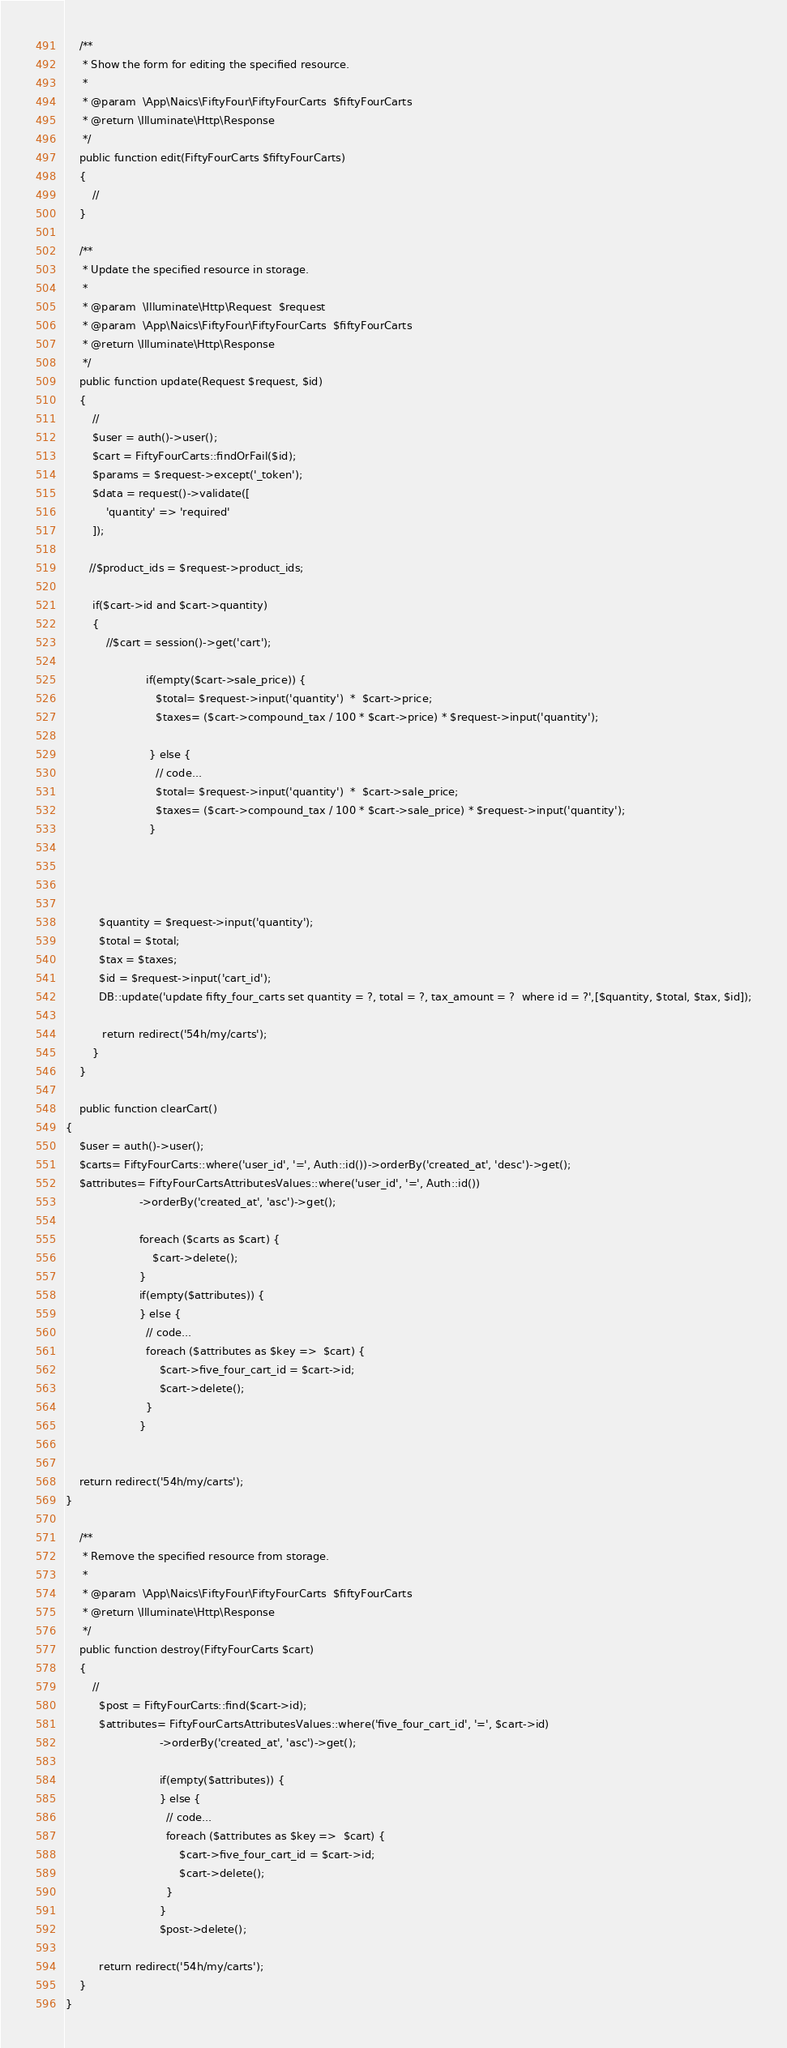Convert code to text. <code><loc_0><loc_0><loc_500><loc_500><_PHP_>    /**
     * Show the form for editing the specified resource.
     *
     * @param  \App\Naics\FiftyFour\FiftyFourCarts  $fiftyFourCarts
     * @return \Illuminate\Http\Response
     */
    public function edit(FiftyFourCarts $fiftyFourCarts)
    {
        //
    }

    /**
     * Update the specified resource in storage.
     *
     * @param  \Illuminate\Http\Request  $request
     * @param  \App\Naics\FiftyFour\FiftyFourCarts  $fiftyFourCarts
     * @return \Illuminate\Http\Response
     */
    public function update(Request $request, $id)
    {
        //
        $user = auth()->user();
        $cart = FiftyFourCarts::findOrFail($id);
        $params = $request->except('_token');
        $data = request()->validate([
            'quantity' => 'required'
        ]);

       //$product_ids = $request->product_ids;

        if($cart->id and $cart->quantity)
        {
            //$cart = session()->get('cart');

                        if(empty($cart->sale_price)) {
                           $total= $request->input('quantity')  *  $cart->price;
                           $taxes= ($cart->compound_tax / 100 * $cart->price) * $request->input('quantity');

                         } else {
                           // code...
                           $total= $request->input('quantity')  *  $cart->sale_price;
                           $taxes= ($cart->compound_tax / 100 * $cart->sale_price) * $request->input('quantity');
                         }




          $quantity = $request->input('quantity');
          $total = $total;
          $tax = $taxes;
          $id = $request->input('cart_id');
          DB::update('update fifty_four_carts set quantity = ?, total = ?, tax_amount = ?  where id = ?',[$quantity, $total, $tax, $id]);

           return redirect('54h/my/carts');
        }
    }

    public function clearCart()
{
    $user = auth()->user();
    $carts= FiftyFourCarts::where('user_id', '=', Auth::id())->orderBy('created_at', 'desc')->get();
    $attributes= FiftyFourCartsAttributesValues::where('user_id', '=', Auth::id())
                      ->orderBy('created_at', 'asc')->get();

                      foreach ($carts as $cart) {
                          $cart->delete();
                      }
                      if(empty($attributes)) {
                      } else {
                        // code...
                        foreach ($attributes as $key =>  $cart) {
                            $cart->five_four_cart_id = $cart->id;
                            $cart->delete();
                        }
                      }


    return redirect('54h/my/carts');
}

    /**
     * Remove the specified resource from storage.
     *
     * @param  \App\Naics\FiftyFour\FiftyFourCarts  $fiftyFourCarts
     * @return \Illuminate\Http\Response
     */
    public function destroy(FiftyFourCarts $cart)
    {
        //
          $post = FiftyFourCarts::find($cart->id);
          $attributes= FiftyFourCartsAttributesValues::where('five_four_cart_id', '=', $cart->id)
                            ->orderBy('created_at', 'asc')->get();

                            if(empty($attributes)) {
                            } else {
                              // code...
                              foreach ($attributes as $key =>  $cart) {
                                  $cart->five_four_cart_id = $cart->id;
                                  $cart->delete();
                              }
                            }
                            $post->delete();

          return redirect('54h/my/carts');
    }
}
</code> 